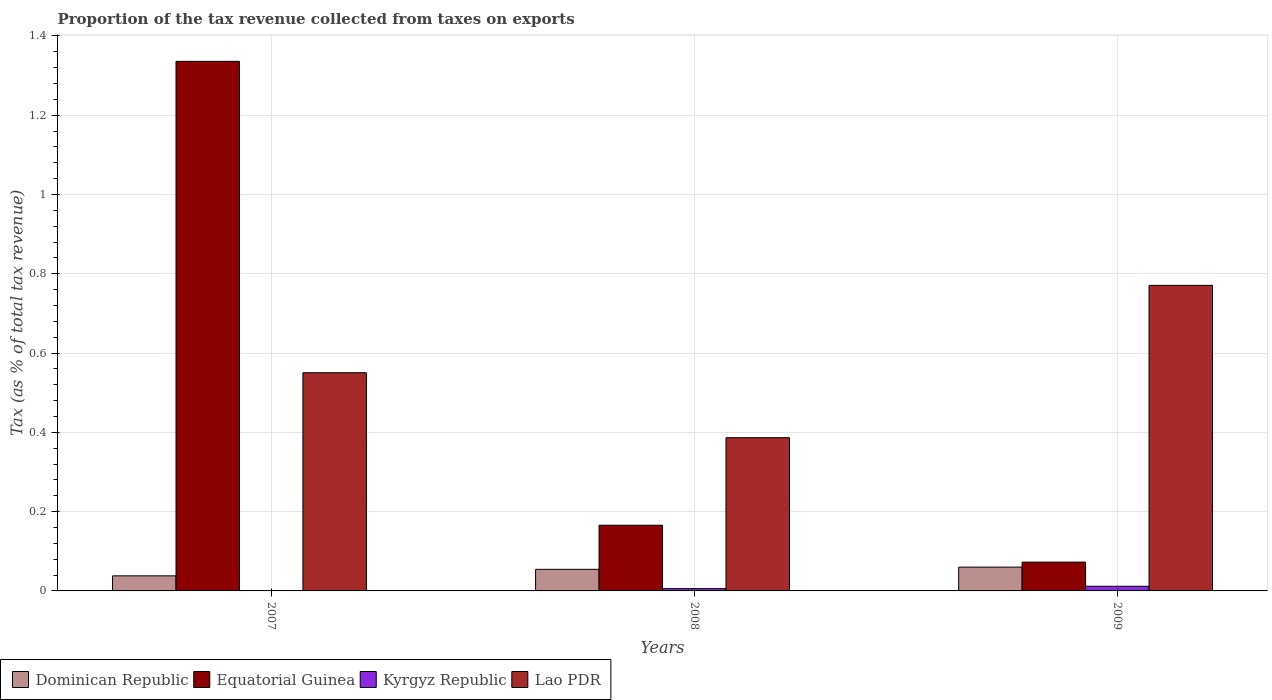How many different coloured bars are there?
Provide a succinct answer. 4. How many groups of bars are there?
Your answer should be compact. 3. How many bars are there on the 1st tick from the right?
Your answer should be very brief. 4. What is the label of the 2nd group of bars from the left?
Provide a short and direct response. 2008. What is the proportion of the tax revenue collected in Lao PDR in 2008?
Offer a very short reply. 0.39. Across all years, what is the maximum proportion of the tax revenue collected in Equatorial Guinea?
Your answer should be very brief. 1.34. Across all years, what is the minimum proportion of the tax revenue collected in Dominican Republic?
Your answer should be compact. 0.04. What is the total proportion of the tax revenue collected in Kyrgyz Republic in the graph?
Your answer should be compact. 0.02. What is the difference between the proportion of the tax revenue collected in Dominican Republic in 2007 and that in 2008?
Your response must be concise. -0.02. What is the difference between the proportion of the tax revenue collected in Kyrgyz Republic in 2007 and the proportion of the tax revenue collected in Dominican Republic in 2009?
Provide a short and direct response. -0.06. What is the average proportion of the tax revenue collected in Kyrgyz Republic per year?
Provide a short and direct response. 0.01. In the year 2009, what is the difference between the proportion of the tax revenue collected in Equatorial Guinea and proportion of the tax revenue collected in Kyrgyz Republic?
Your answer should be compact. 0.06. What is the ratio of the proportion of the tax revenue collected in Equatorial Guinea in 2007 to that in 2009?
Your answer should be very brief. 18.38. Is the difference between the proportion of the tax revenue collected in Equatorial Guinea in 2008 and 2009 greater than the difference between the proportion of the tax revenue collected in Kyrgyz Republic in 2008 and 2009?
Your response must be concise. Yes. What is the difference between the highest and the second highest proportion of the tax revenue collected in Dominican Republic?
Ensure brevity in your answer.  0.01. What is the difference between the highest and the lowest proportion of the tax revenue collected in Kyrgyz Republic?
Offer a terse response. 0.01. What does the 2nd bar from the left in 2007 represents?
Make the answer very short. Equatorial Guinea. What does the 1st bar from the right in 2008 represents?
Your answer should be compact. Lao PDR. Is it the case that in every year, the sum of the proportion of the tax revenue collected in Dominican Republic and proportion of the tax revenue collected in Lao PDR is greater than the proportion of the tax revenue collected in Equatorial Guinea?
Offer a very short reply. No. What is the difference between two consecutive major ticks on the Y-axis?
Ensure brevity in your answer.  0.2. Does the graph contain any zero values?
Offer a very short reply. No. Does the graph contain grids?
Make the answer very short. Yes. Where does the legend appear in the graph?
Your answer should be very brief. Bottom left. How many legend labels are there?
Offer a terse response. 4. What is the title of the graph?
Ensure brevity in your answer.  Proportion of the tax revenue collected from taxes on exports. Does "United States" appear as one of the legend labels in the graph?
Make the answer very short. No. What is the label or title of the Y-axis?
Offer a terse response. Tax (as % of total tax revenue). What is the Tax (as % of total tax revenue) in Dominican Republic in 2007?
Your answer should be compact. 0.04. What is the Tax (as % of total tax revenue) in Equatorial Guinea in 2007?
Provide a short and direct response. 1.34. What is the Tax (as % of total tax revenue) of Kyrgyz Republic in 2007?
Your answer should be very brief. 0. What is the Tax (as % of total tax revenue) in Lao PDR in 2007?
Your answer should be compact. 0.55. What is the Tax (as % of total tax revenue) of Dominican Republic in 2008?
Provide a short and direct response. 0.05. What is the Tax (as % of total tax revenue) in Equatorial Guinea in 2008?
Make the answer very short. 0.17. What is the Tax (as % of total tax revenue) in Kyrgyz Republic in 2008?
Your answer should be very brief. 0.01. What is the Tax (as % of total tax revenue) of Lao PDR in 2008?
Offer a terse response. 0.39. What is the Tax (as % of total tax revenue) of Dominican Republic in 2009?
Offer a very short reply. 0.06. What is the Tax (as % of total tax revenue) in Equatorial Guinea in 2009?
Your answer should be compact. 0.07. What is the Tax (as % of total tax revenue) in Kyrgyz Republic in 2009?
Provide a short and direct response. 0.01. What is the Tax (as % of total tax revenue) in Lao PDR in 2009?
Provide a short and direct response. 0.77. Across all years, what is the maximum Tax (as % of total tax revenue) of Dominican Republic?
Ensure brevity in your answer.  0.06. Across all years, what is the maximum Tax (as % of total tax revenue) in Equatorial Guinea?
Your answer should be very brief. 1.34. Across all years, what is the maximum Tax (as % of total tax revenue) in Kyrgyz Republic?
Offer a terse response. 0.01. Across all years, what is the maximum Tax (as % of total tax revenue) in Lao PDR?
Provide a short and direct response. 0.77. Across all years, what is the minimum Tax (as % of total tax revenue) in Dominican Republic?
Keep it short and to the point. 0.04. Across all years, what is the minimum Tax (as % of total tax revenue) of Equatorial Guinea?
Your answer should be very brief. 0.07. Across all years, what is the minimum Tax (as % of total tax revenue) in Kyrgyz Republic?
Give a very brief answer. 0. Across all years, what is the minimum Tax (as % of total tax revenue) of Lao PDR?
Provide a succinct answer. 0.39. What is the total Tax (as % of total tax revenue) of Dominican Republic in the graph?
Offer a very short reply. 0.15. What is the total Tax (as % of total tax revenue) of Equatorial Guinea in the graph?
Provide a succinct answer. 1.57. What is the total Tax (as % of total tax revenue) in Kyrgyz Republic in the graph?
Ensure brevity in your answer.  0.02. What is the total Tax (as % of total tax revenue) in Lao PDR in the graph?
Keep it short and to the point. 1.71. What is the difference between the Tax (as % of total tax revenue) of Dominican Republic in 2007 and that in 2008?
Offer a terse response. -0.02. What is the difference between the Tax (as % of total tax revenue) in Equatorial Guinea in 2007 and that in 2008?
Give a very brief answer. 1.17. What is the difference between the Tax (as % of total tax revenue) in Kyrgyz Republic in 2007 and that in 2008?
Provide a succinct answer. -0.01. What is the difference between the Tax (as % of total tax revenue) in Lao PDR in 2007 and that in 2008?
Your answer should be very brief. 0.16. What is the difference between the Tax (as % of total tax revenue) in Dominican Republic in 2007 and that in 2009?
Offer a very short reply. -0.02. What is the difference between the Tax (as % of total tax revenue) in Equatorial Guinea in 2007 and that in 2009?
Offer a terse response. 1.26. What is the difference between the Tax (as % of total tax revenue) in Kyrgyz Republic in 2007 and that in 2009?
Provide a succinct answer. -0.01. What is the difference between the Tax (as % of total tax revenue) in Lao PDR in 2007 and that in 2009?
Provide a succinct answer. -0.22. What is the difference between the Tax (as % of total tax revenue) of Dominican Republic in 2008 and that in 2009?
Keep it short and to the point. -0.01. What is the difference between the Tax (as % of total tax revenue) in Equatorial Guinea in 2008 and that in 2009?
Keep it short and to the point. 0.09. What is the difference between the Tax (as % of total tax revenue) of Kyrgyz Republic in 2008 and that in 2009?
Your answer should be compact. -0.01. What is the difference between the Tax (as % of total tax revenue) in Lao PDR in 2008 and that in 2009?
Keep it short and to the point. -0.38. What is the difference between the Tax (as % of total tax revenue) in Dominican Republic in 2007 and the Tax (as % of total tax revenue) in Equatorial Guinea in 2008?
Provide a succinct answer. -0.13. What is the difference between the Tax (as % of total tax revenue) of Dominican Republic in 2007 and the Tax (as % of total tax revenue) of Kyrgyz Republic in 2008?
Your answer should be very brief. 0.03. What is the difference between the Tax (as % of total tax revenue) of Dominican Republic in 2007 and the Tax (as % of total tax revenue) of Lao PDR in 2008?
Your response must be concise. -0.35. What is the difference between the Tax (as % of total tax revenue) of Equatorial Guinea in 2007 and the Tax (as % of total tax revenue) of Kyrgyz Republic in 2008?
Offer a very short reply. 1.33. What is the difference between the Tax (as % of total tax revenue) of Equatorial Guinea in 2007 and the Tax (as % of total tax revenue) of Lao PDR in 2008?
Ensure brevity in your answer.  0.95. What is the difference between the Tax (as % of total tax revenue) in Kyrgyz Republic in 2007 and the Tax (as % of total tax revenue) in Lao PDR in 2008?
Give a very brief answer. -0.39. What is the difference between the Tax (as % of total tax revenue) in Dominican Republic in 2007 and the Tax (as % of total tax revenue) in Equatorial Guinea in 2009?
Offer a terse response. -0.03. What is the difference between the Tax (as % of total tax revenue) in Dominican Republic in 2007 and the Tax (as % of total tax revenue) in Kyrgyz Republic in 2009?
Make the answer very short. 0.03. What is the difference between the Tax (as % of total tax revenue) in Dominican Republic in 2007 and the Tax (as % of total tax revenue) in Lao PDR in 2009?
Offer a very short reply. -0.73. What is the difference between the Tax (as % of total tax revenue) in Equatorial Guinea in 2007 and the Tax (as % of total tax revenue) in Kyrgyz Republic in 2009?
Offer a terse response. 1.32. What is the difference between the Tax (as % of total tax revenue) in Equatorial Guinea in 2007 and the Tax (as % of total tax revenue) in Lao PDR in 2009?
Your response must be concise. 0.56. What is the difference between the Tax (as % of total tax revenue) in Kyrgyz Republic in 2007 and the Tax (as % of total tax revenue) in Lao PDR in 2009?
Offer a very short reply. -0.77. What is the difference between the Tax (as % of total tax revenue) in Dominican Republic in 2008 and the Tax (as % of total tax revenue) in Equatorial Guinea in 2009?
Make the answer very short. -0.02. What is the difference between the Tax (as % of total tax revenue) in Dominican Republic in 2008 and the Tax (as % of total tax revenue) in Kyrgyz Republic in 2009?
Give a very brief answer. 0.04. What is the difference between the Tax (as % of total tax revenue) of Dominican Republic in 2008 and the Tax (as % of total tax revenue) of Lao PDR in 2009?
Offer a very short reply. -0.72. What is the difference between the Tax (as % of total tax revenue) of Equatorial Guinea in 2008 and the Tax (as % of total tax revenue) of Kyrgyz Republic in 2009?
Your answer should be very brief. 0.15. What is the difference between the Tax (as % of total tax revenue) of Equatorial Guinea in 2008 and the Tax (as % of total tax revenue) of Lao PDR in 2009?
Your answer should be compact. -0.6. What is the difference between the Tax (as % of total tax revenue) of Kyrgyz Republic in 2008 and the Tax (as % of total tax revenue) of Lao PDR in 2009?
Your answer should be compact. -0.76. What is the average Tax (as % of total tax revenue) of Dominican Republic per year?
Your answer should be compact. 0.05. What is the average Tax (as % of total tax revenue) of Equatorial Guinea per year?
Your response must be concise. 0.52. What is the average Tax (as % of total tax revenue) of Kyrgyz Republic per year?
Keep it short and to the point. 0.01. What is the average Tax (as % of total tax revenue) in Lao PDR per year?
Provide a succinct answer. 0.57. In the year 2007, what is the difference between the Tax (as % of total tax revenue) of Dominican Republic and Tax (as % of total tax revenue) of Equatorial Guinea?
Provide a short and direct response. -1.3. In the year 2007, what is the difference between the Tax (as % of total tax revenue) of Dominican Republic and Tax (as % of total tax revenue) of Kyrgyz Republic?
Provide a succinct answer. 0.04. In the year 2007, what is the difference between the Tax (as % of total tax revenue) in Dominican Republic and Tax (as % of total tax revenue) in Lao PDR?
Your response must be concise. -0.51. In the year 2007, what is the difference between the Tax (as % of total tax revenue) in Equatorial Guinea and Tax (as % of total tax revenue) in Kyrgyz Republic?
Ensure brevity in your answer.  1.34. In the year 2007, what is the difference between the Tax (as % of total tax revenue) in Equatorial Guinea and Tax (as % of total tax revenue) in Lao PDR?
Keep it short and to the point. 0.79. In the year 2007, what is the difference between the Tax (as % of total tax revenue) of Kyrgyz Republic and Tax (as % of total tax revenue) of Lao PDR?
Provide a succinct answer. -0.55. In the year 2008, what is the difference between the Tax (as % of total tax revenue) in Dominican Republic and Tax (as % of total tax revenue) in Equatorial Guinea?
Your response must be concise. -0.11. In the year 2008, what is the difference between the Tax (as % of total tax revenue) in Dominican Republic and Tax (as % of total tax revenue) in Kyrgyz Republic?
Give a very brief answer. 0.05. In the year 2008, what is the difference between the Tax (as % of total tax revenue) of Dominican Republic and Tax (as % of total tax revenue) of Lao PDR?
Offer a very short reply. -0.33. In the year 2008, what is the difference between the Tax (as % of total tax revenue) of Equatorial Guinea and Tax (as % of total tax revenue) of Kyrgyz Republic?
Your response must be concise. 0.16. In the year 2008, what is the difference between the Tax (as % of total tax revenue) in Equatorial Guinea and Tax (as % of total tax revenue) in Lao PDR?
Keep it short and to the point. -0.22. In the year 2008, what is the difference between the Tax (as % of total tax revenue) of Kyrgyz Republic and Tax (as % of total tax revenue) of Lao PDR?
Your answer should be very brief. -0.38. In the year 2009, what is the difference between the Tax (as % of total tax revenue) of Dominican Republic and Tax (as % of total tax revenue) of Equatorial Guinea?
Offer a terse response. -0.01. In the year 2009, what is the difference between the Tax (as % of total tax revenue) in Dominican Republic and Tax (as % of total tax revenue) in Kyrgyz Republic?
Ensure brevity in your answer.  0.05. In the year 2009, what is the difference between the Tax (as % of total tax revenue) in Dominican Republic and Tax (as % of total tax revenue) in Lao PDR?
Offer a terse response. -0.71. In the year 2009, what is the difference between the Tax (as % of total tax revenue) in Equatorial Guinea and Tax (as % of total tax revenue) in Kyrgyz Republic?
Make the answer very short. 0.06. In the year 2009, what is the difference between the Tax (as % of total tax revenue) in Equatorial Guinea and Tax (as % of total tax revenue) in Lao PDR?
Provide a succinct answer. -0.7. In the year 2009, what is the difference between the Tax (as % of total tax revenue) in Kyrgyz Republic and Tax (as % of total tax revenue) in Lao PDR?
Give a very brief answer. -0.76. What is the ratio of the Tax (as % of total tax revenue) of Dominican Republic in 2007 to that in 2008?
Keep it short and to the point. 0.7. What is the ratio of the Tax (as % of total tax revenue) in Equatorial Guinea in 2007 to that in 2008?
Provide a short and direct response. 8.06. What is the ratio of the Tax (as % of total tax revenue) of Kyrgyz Republic in 2007 to that in 2008?
Your response must be concise. 0.11. What is the ratio of the Tax (as % of total tax revenue) in Lao PDR in 2007 to that in 2008?
Make the answer very short. 1.42. What is the ratio of the Tax (as % of total tax revenue) in Dominican Republic in 2007 to that in 2009?
Give a very brief answer. 0.63. What is the ratio of the Tax (as % of total tax revenue) of Equatorial Guinea in 2007 to that in 2009?
Make the answer very short. 18.38. What is the ratio of the Tax (as % of total tax revenue) of Kyrgyz Republic in 2007 to that in 2009?
Give a very brief answer. 0.05. What is the ratio of the Tax (as % of total tax revenue) in Lao PDR in 2007 to that in 2009?
Your answer should be very brief. 0.71. What is the ratio of the Tax (as % of total tax revenue) in Dominican Republic in 2008 to that in 2009?
Give a very brief answer. 0.91. What is the ratio of the Tax (as % of total tax revenue) in Equatorial Guinea in 2008 to that in 2009?
Offer a very short reply. 2.28. What is the ratio of the Tax (as % of total tax revenue) of Kyrgyz Republic in 2008 to that in 2009?
Provide a succinct answer. 0.49. What is the ratio of the Tax (as % of total tax revenue) in Lao PDR in 2008 to that in 2009?
Your response must be concise. 0.5. What is the difference between the highest and the second highest Tax (as % of total tax revenue) of Dominican Republic?
Your answer should be very brief. 0.01. What is the difference between the highest and the second highest Tax (as % of total tax revenue) in Equatorial Guinea?
Your response must be concise. 1.17. What is the difference between the highest and the second highest Tax (as % of total tax revenue) of Kyrgyz Republic?
Provide a succinct answer. 0.01. What is the difference between the highest and the second highest Tax (as % of total tax revenue) of Lao PDR?
Give a very brief answer. 0.22. What is the difference between the highest and the lowest Tax (as % of total tax revenue) of Dominican Republic?
Provide a short and direct response. 0.02. What is the difference between the highest and the lowest Tax (as % of total tax revenue) of Equatorial Guinea?
Your answer should be compact. 1.26. What is the difference between the highest and the lowest Tax (as % of total tax revenue) in Kyrgyz Republic?
Your answer should be very brief. 0.01. What is the difference between the highest and the lowest Tax (as % of total tax revenue) of Lao PDR?
Make the answer very short. 0.38. 